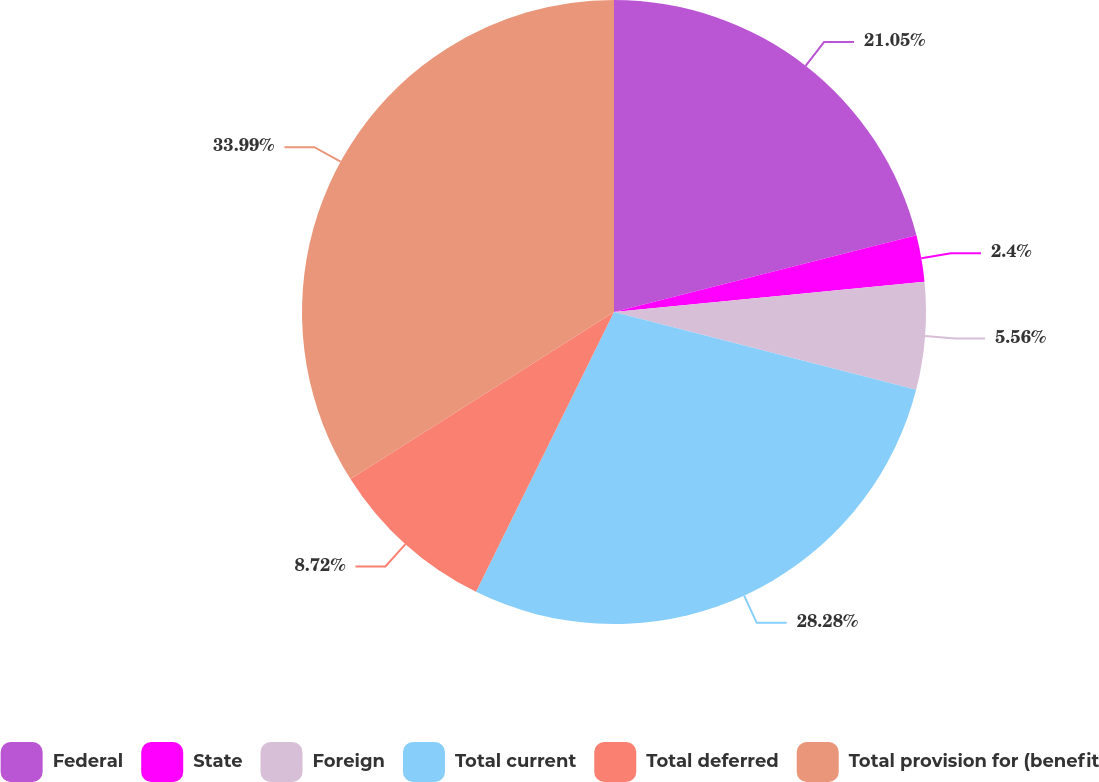Convert chart. <chart><loc_0><loc_0><loc_500><loc_500><pie_chart><fcel>Federal<fcel>State<fcel>Foreign<fcel>Total current<fcel>Total deferred<fcel>Total provision for (benefit<nl><fcel>21.05%<fcel>2.4%<fcel>5.56%<fcel>28.28%<fcel>8.72%<fcel>33.99%<nl></chart> 